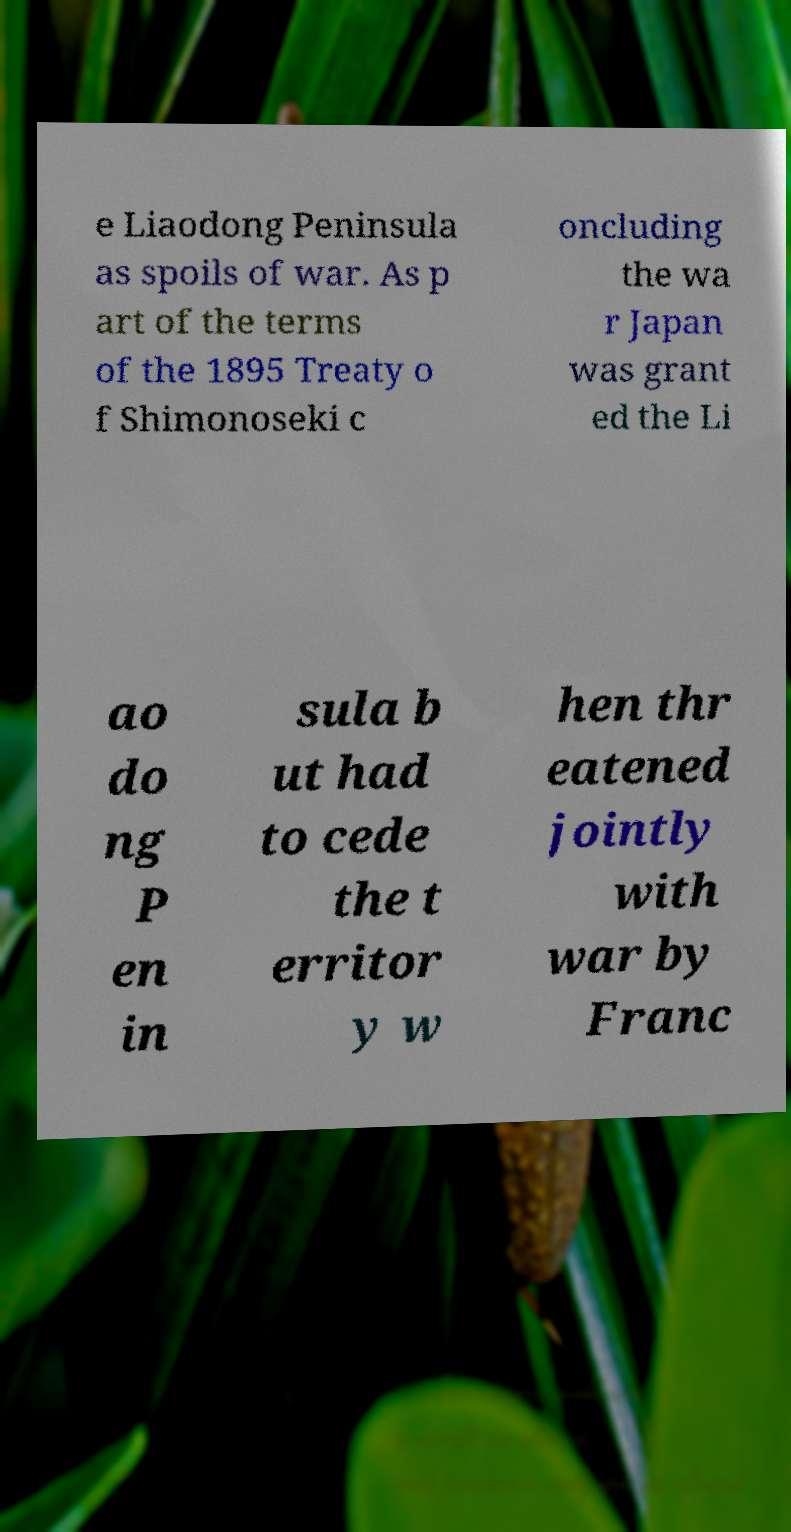I need the written content from this picture converted into text. Can you do that? e Liaodong Peninsula as spoils of war. As p art of the terms of the 1895 Treaty o f Shimonoseki c oncluding the wa r Japan was grant ed the Li ao do ng P en in sula b ut had to cede the t erritor y w hen thr eatened jointly with war by Franc 